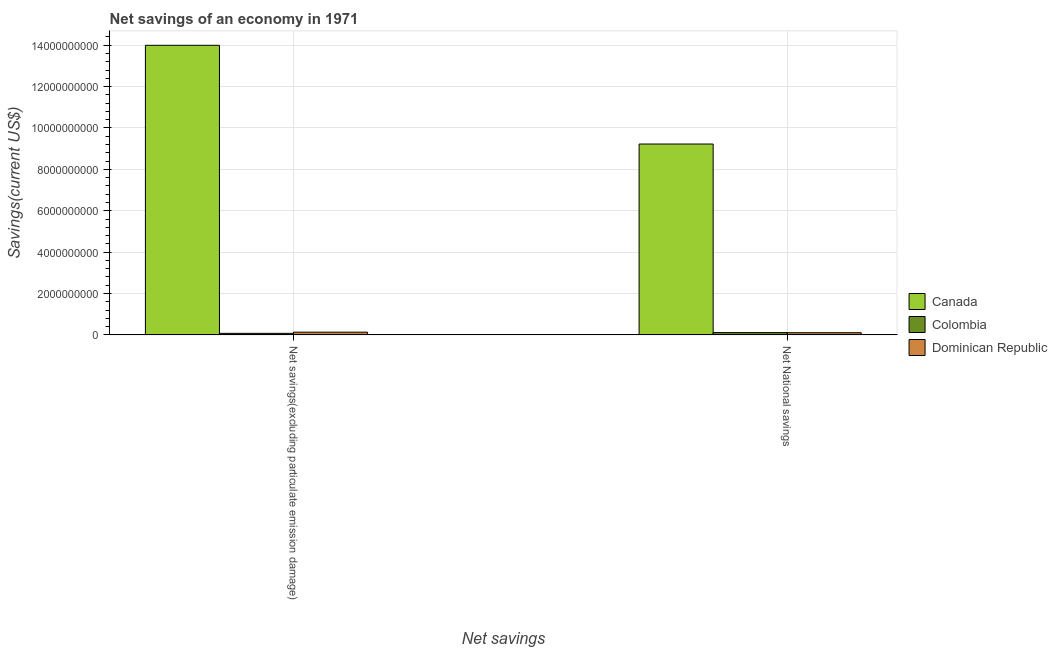How many different coloured bars are there?
Provide a succinct answer. 3. Are the number of bars on each tick of the X-axis equal?
Make the answer very short. Yes. How many bars are there on the 2nd tick from the left?
Your answer should be very brief. 3. What is the label of the 1st group of bars from the left?
Offer a terse response. Net savings(excluding particulate emission damage). What is the net savings(excluding particulate emission damage) in Dominican Republic?
Make the answer very short. 1.32e+08. Across all countries, what is the maximum net savings(excluding particulate emission damage)?
Your answer should be compact. 1.40e+1. Across all countries, what is the minimum net national savings?
Your response must be concise. 1.05e+08. In which country was the net national savings maximum?
Ensure brevity in your answer.  Canada. In which country was the net national savings minimum?
Give a very brief answer. Dominican Republic. What is the total net national savings in the graph?
Your answer should be compact. 9.44e+09. What is the difference between the net savings(excluding particulate emission damage) in Colombia and that in Canada?
Your answer should be very brief. -1.39e+1. What is the difference between the net national savings in Dominican Republic and the net savings(excluding particulate emission damage) in Canada?
Provide a succinct answer. -1.39e+1. What is the average net national savings per country?
Your answer should be very brief. 3.15e+09. What is the difference between the net savings(excluding particulate emission damage) and net national savings in Canada?
Ensure brevity in your answer.  4.77e+09. In how many countries, is the net savings(excluding particulate emission damage) greater than 12400000000 US$?
Make the answer very short. 1. What is the ratio of the net savings(excluding particulate emission damage) in Colombia to that in Dominican Republic?
Your answer should be compact. 0.57. What does the 3rd bar from the left in Net National savings represents?
Keep it short and to the point. Dominican Republic. What does the 1st bar from the right in Net National savings represents?
Offer a very short reply. Dominican Republic. What is the difference between two consecutive major ticks on the Y-axis?
Offer a very short reply. 2.00e+09. Does the graph contain grids?
Make the answer very short. Yes. How are the legend labels stacked?
Provide a succinct answer. Vertical. What is the title of the graph?
Your answer should be compact. Net savings of an economy in 1971. What is the label or title of the X-axis?
Offer a terse response. Net savings. What is the label or title of the Y-axis?
Ensure brevity in your answer.  Savings(current US$). What is the Savings(current US$) of Canada in Net savings(excluding particulate emission damage)?
Your response must be concise. 1.40e+1. What is the Savings(current US$) in Colombia in Net savings(excluding particulate emission damage)?
Give a very brief answer. 7.46e+07. What is the Savings(current US$) of Dominican Republic in Net savings(excluding particulate emission damage)?
Provide a short and direct response. 1.32e+08. What is the Savings(current US$) of Canada in Net National savings?
Offer a terse response. 9.23e+09. What is the Savings(current US$) of Colombia in Net National savings?
Ensure brevity in your answer.  1.11e+08. What is the Savings(current US$) in Dominican Republic in Net National savings?
Your response must be concise. 1.05e+08. Across all Net savings, what is the maximum Savings(current US$) of Canada?
Your answer should be very brief. 1.40e+1. Across all Net savings, what is the maximum Savings(current US$) in Colombia?
Ensure brevity in your answer.  1.11e+08. Across all Net savings, what is the maximum Savings(current US$) in Dominican Republic?
Offer a very short reply. 1.32e+08. Across all Net savings, what is the minimum Savings(current US$) of Canada?
Your answer should be compact. 9.23e+09. Across all Net savings, what is the minimum Savings(current US$) of Colombia?
Offer a terse response. 7.46e+07. Across all Net savings, what is the minimum Savings(current US$) in Dominican Republic?
Make the answer very short. 1.05e+08. What is the total Savings(current US$) in Canada in the graph?
Give a very brief answer. 2.32e+1. What is the total Savings(current US$) of Colombia in the graph?
Offer a terse response. 1.86e+08. What is the total Savings(current US$) of Dominican Republic in the graph?
Give a very brief answer. 2.37e+08. What is the difference between the Savings(current US$) in Canada in Net savings(excluding particulate emission damage) and that in Net National savings?
Your response must be concise. 4.77e+09. What is the difference between the Savings(current US$) of Colombia in Net savings(excluding particulate emission damage) and that in Net National savings?
Provide a succinct answer. -3.68e+07. What is the difference between the Savings(current US$) of Dominican Republic in Net savings(excluding particulate emission damage) and that in Net National savings?
Give a very brief answer. 2.61e+07. What is the difference between the Savings(current US$) of Canada in Net savings(excluding particulate emission damage) and the Savings(current US$) of Colombia in Net National savings?
Keep it short and to the point. 1.39e+1. What is the difference between the Savings(current US$) in Canada in Net savings(excluding particulate emission damage) and the Savings(current US$) in Dominican Republic in Net National savings?
Offer a terse response. 1.39e+1. What is the difference between the Savings(current US$) of Colombia in Net savings(excluding particulate emission damage) and the Savings(current US$) of Dominican Republic in Net National savings?
Ensure brevity in your answer.  -3.08e+07. What is the average Savings(current US$) of Canada per Net savings?
Offer a terse response. 1.16e+1. What is the average Savings(current US$) of Colombia per Net savings?
Provide a succinct answer. 9.30e+07. What is the average Savings(current US$) of Dominican Republic per Net savings?
Provide a short and direct response. 1.18e+08. What is the difference between the Savings(current US$) in Canada and Savings(current US$) in Colombia in Net savings(excluding particulate emission damage)?
Ensure brevity in your answer.  1.39e+1. What is the difference between the Savings(current US$) in Canada and Savings(current US$) in Dominican Republic in Net savings(excluding particulate emission damage)?
Offer a terse response. 1.39e+1. What is the difference between the Savings(current US$) of Colombia and Savings(current US$) of Dominican Republic in Net savings(excluding particulate emission damage)?
Provide a short and direct response. -5.69e+07. What is the difference between the Savings(current US$) in Canada and Savings(current US$) in Colombia in Net National savings?
Your answer should be very brief. 9.11e+09. What is the difference between the Savings(current US$) of Canada and Savings(current US$) of Dominican Republic in Net National savings?
Ensure brevity in your answer.  9.12e+09. What is the difference between the Savings(current US$) of Colombia and Savings(current US$) of Dominican Republic in Net National savings?
Give a very brief answer. 6.03e+06. What is the ratio of the Savings(current US$) in Canada in Net savings(excluding particulate emission damage) to that in Net National savings?
Your response must be concise. 1.52. What is the ratio of the Savings(current US$) in Colombia in Net savings(excluding particulate emission damage) to that in Net National savings?
Provide a succinct answer. 0.67. What is the ratio of the Savings(current US$) in Dominican Republic in Net savings(excluding particulate emission damage) to that in Net National savings?
Offer a terse response. 1.25. What is the difference between the highest and the second highest Savings(current US$) of Canada?
Ensure brevity in your answer.  4.77e+09. What is the difference between the highest and the second highest Savings(current US$) in Colombia?
Make the answer very short. 3.68e+07. What is the difference between the highest and the second highest Savings(current US$) of Dominican Republic?
Offer a terse response. 2.61e+07. What is the difference between the highest and the lowest Savings(current US$) in Canada?
Your answer should be very brief. 4.77e+09. What is the difference between the highest and the lowest Savings(current US$) of Colombia?
Ensure brevity in your answer.  3.68e+07. What is the difference between the highest and the lowest Savings(current US$) of Dominican Republic?
Your response must be concise. 2.61e+07. 